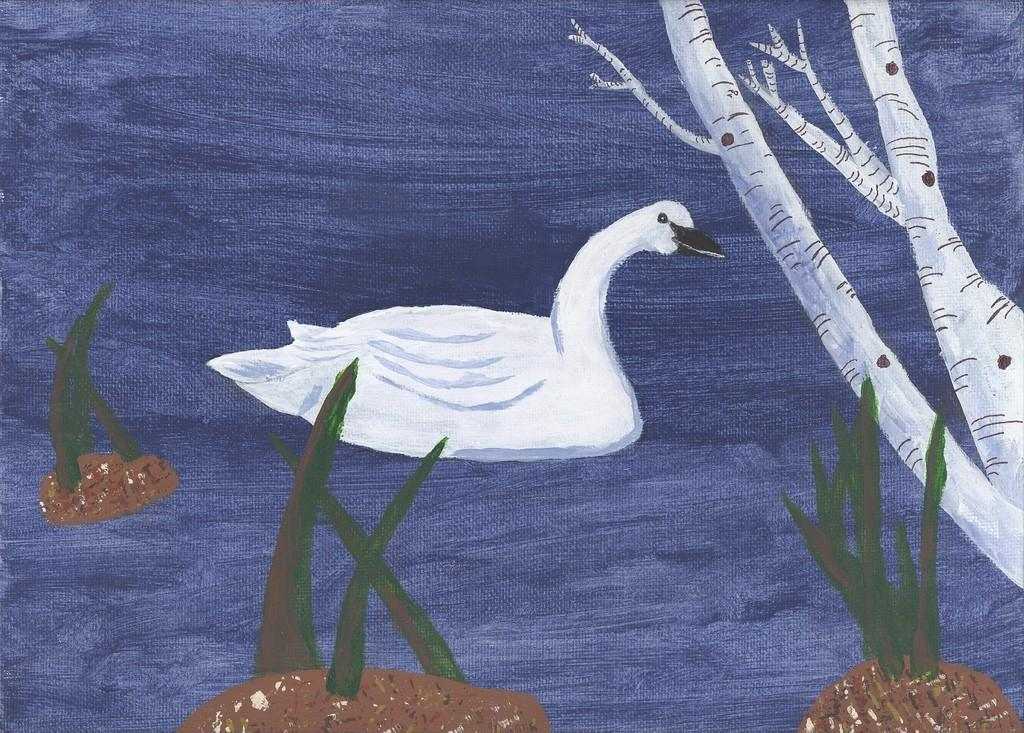What type of artwork is the image? The image is a painting. What is the main subject of the painting? There is a picture of a swan in the middle of the image. What other elements are present in the painting? There are leaves depicted in the image. Where is the stem of a tree located in the painting? There is a stem of a tree at the bottom of the image. What type of bells can be heard ringing in the image? There are no bells present in the image, and therefore no sound can be heard. Is there a knot tied around the swan's neck in the image? There is no knot tied around the swan's neck in the image; the swan is depicted without any additional accessories. 